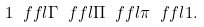<formula> <loc_0><loc_0><loc_500><loc_500>1 \ f f l \Gamma \ f f l \Pi \ f f l \pi \ f f l 1 .</formula> 